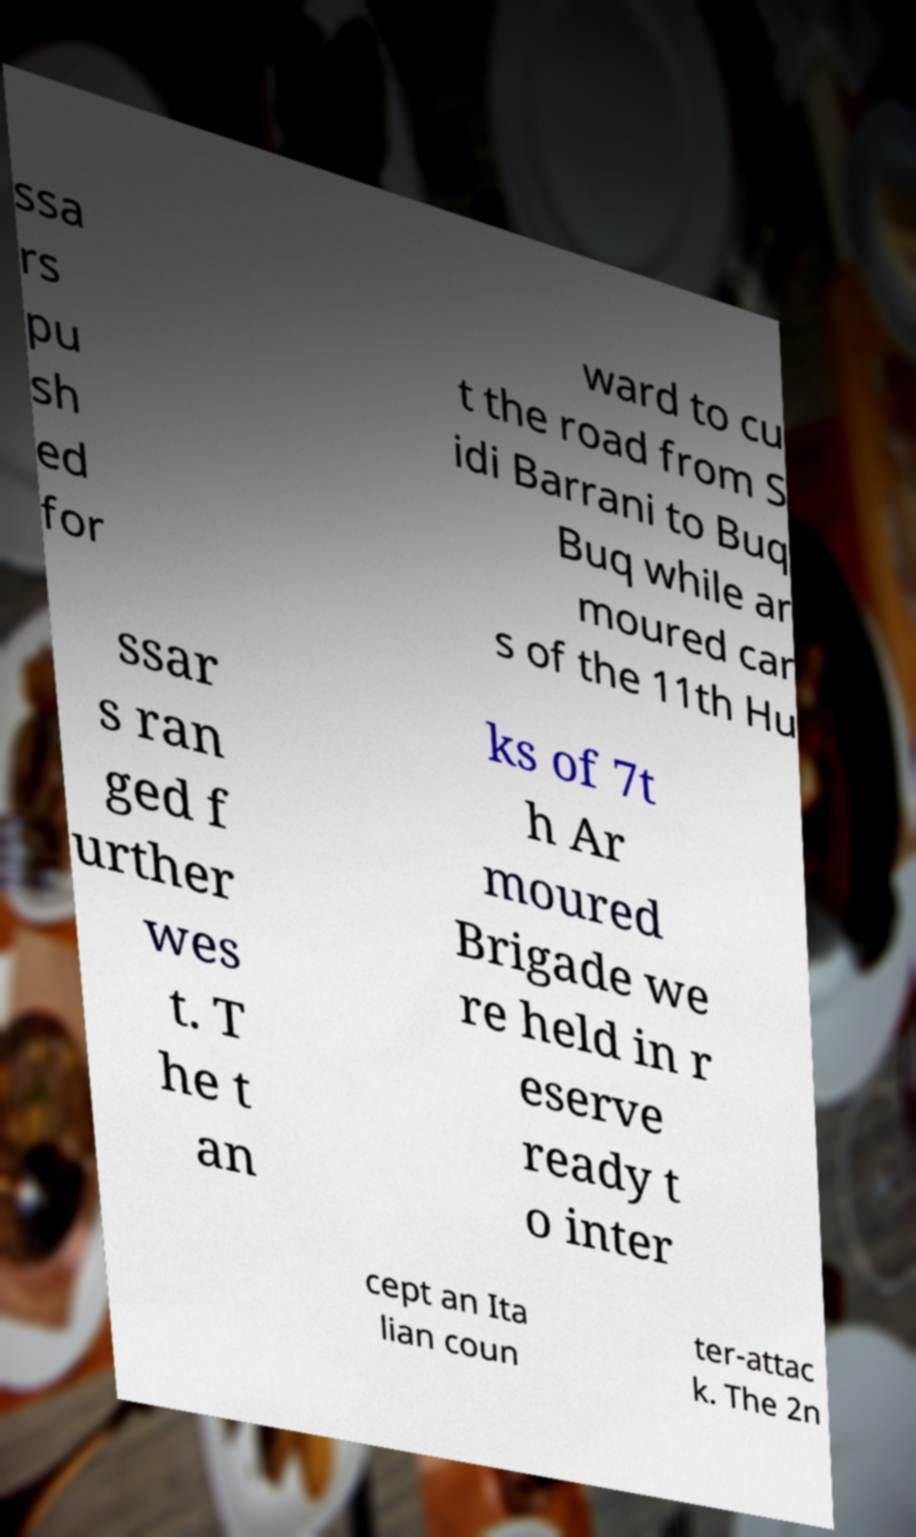Please identify and transcribe the text found in this image. ssa rs pu sh ed for ward to cu t the road from S idi Barrani to Buq Buq while ar moured car s of the 11th Hu ssar s ran ged f urther wes t. T he t an ks of 7t h Ar moured Brigade we re held in r eserve ready t o inter cept an Ita lian coun ter-attac k. The 2n 